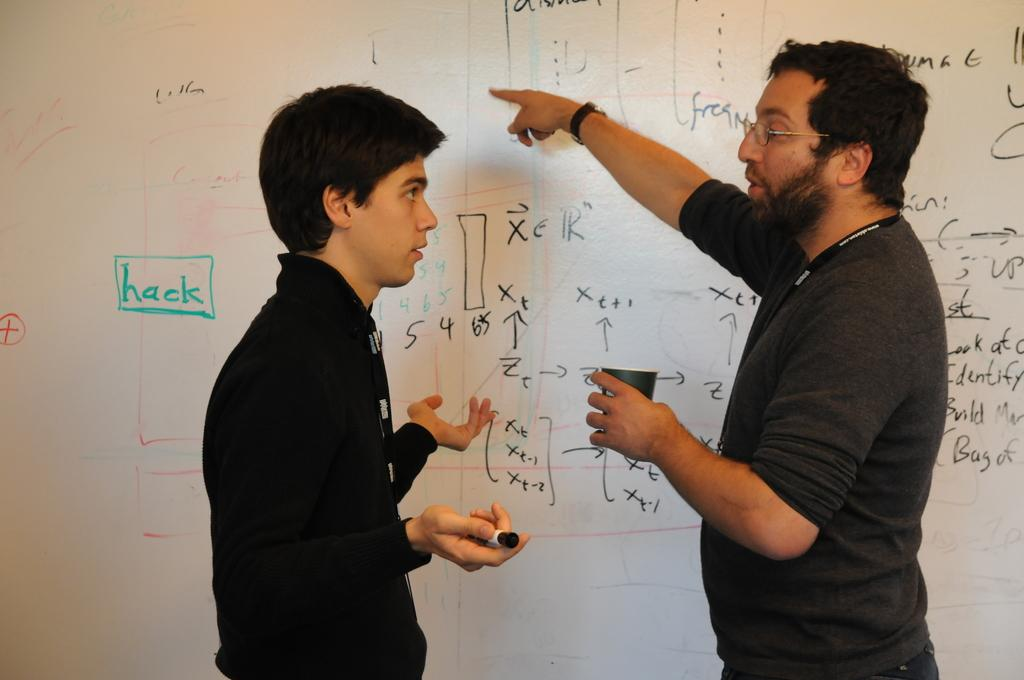<image>
Describe the image concisely. A man explaining math figures on the white board and hack written in green. 